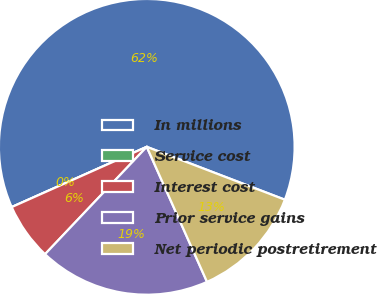Convert chart. <chart><loc_0><loc_0><loc_500><loc_500><pie_chart><fcel>In millions<fcel>Service cost<fcel>Interest cost<fcel>Prior service gains<fcel>Net periodic postretirement<nl><fcel>62.49%<fcel>0.0%<fcel>6.25%<fcel>18.75%<fcel>12.5%<nl></chart> 